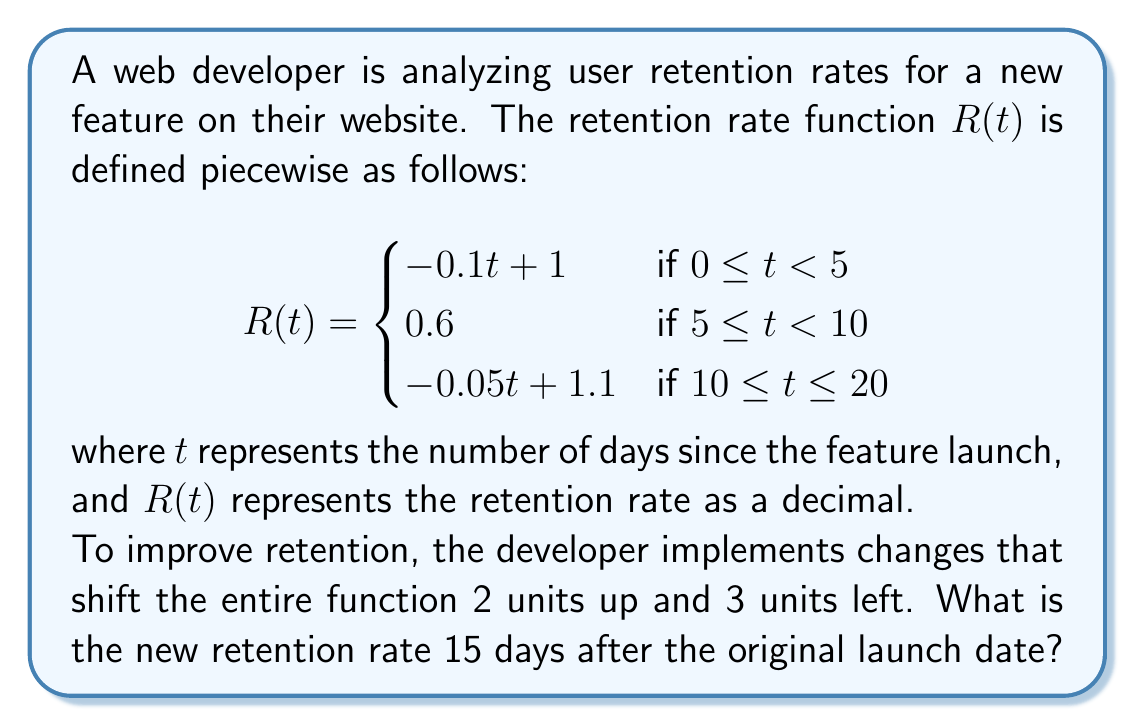Give your solution to this math problem. Let's approach this step-by-step:

1) First, we need to understand the transformations applied to the function:
   - Shifting 2 units up: $R(t) \rightarrow R(t) + 2$
   - Shifting 3 units left: $R(t) \rightarrow R(t+3)$

2) Combining these transformations, our new function $R_{new}(t)$ is:
   $R_{new}(t) = R(t+3) + 2$

3) We need to find $R_{new}(15)$, which is equivalent to $R(18) + 2$

4) To find $R(18)$, we need to use the third piece of the original piecewise function, as $18$ falls in the range $10 \leq t \leq 20$:

   $R(18) = -0.05(18) + 1.1$

5) Let's calculate this:
   $R(18) = -0.9 + 1.1 = 0.2$

6) Now, we apply the vertical shift of 2 units:
   $R_{new}(15) = R(18) + 2 = 0.2 + 2 = 2.2$

Therefore, the new retention rate 15 days after the original launch date is 2.2, or 220%.
Answer: $2.2$ or $220\%$ 